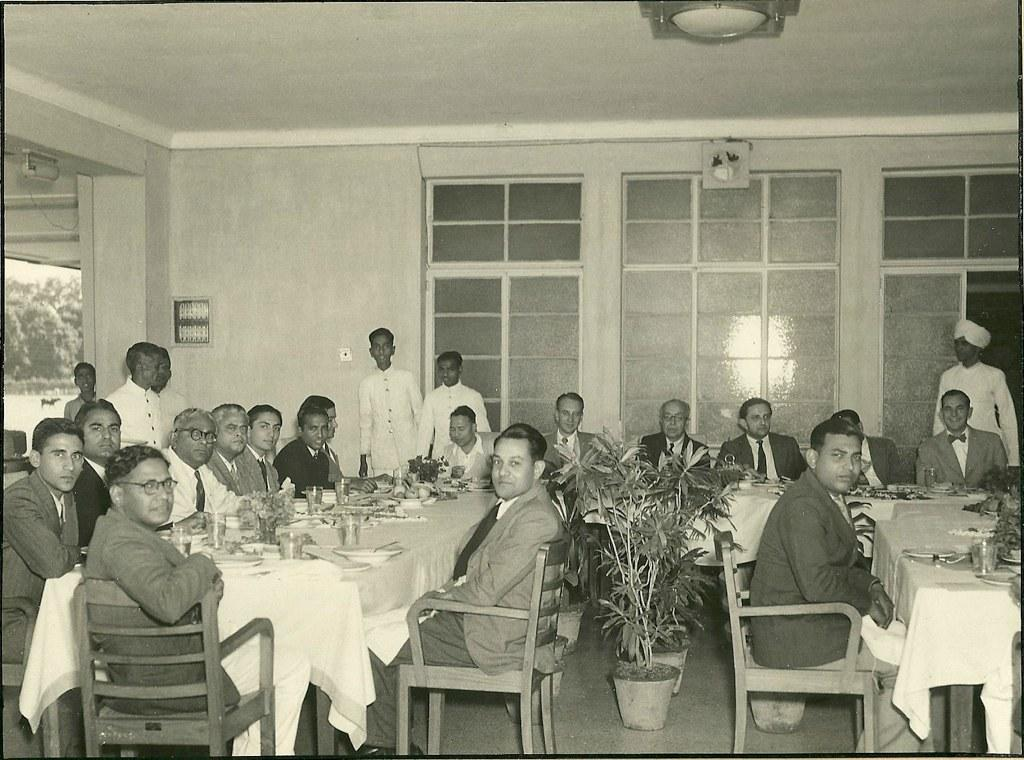What are the people in the image doing? There are people sitting on chairs and standing in the image. What can be seen in the image besides the people? There is a plant and a table in the image. What is on the table in the image? There are items on the tables in the image. What type of goose is sitting on the table in the image? There is no goose present in the image; it only features people, a plant, and items on the table. What invention is being demonstrated by the people in the image? There is no invention being demonstrated in the image; the people are simply sitting or standing. 